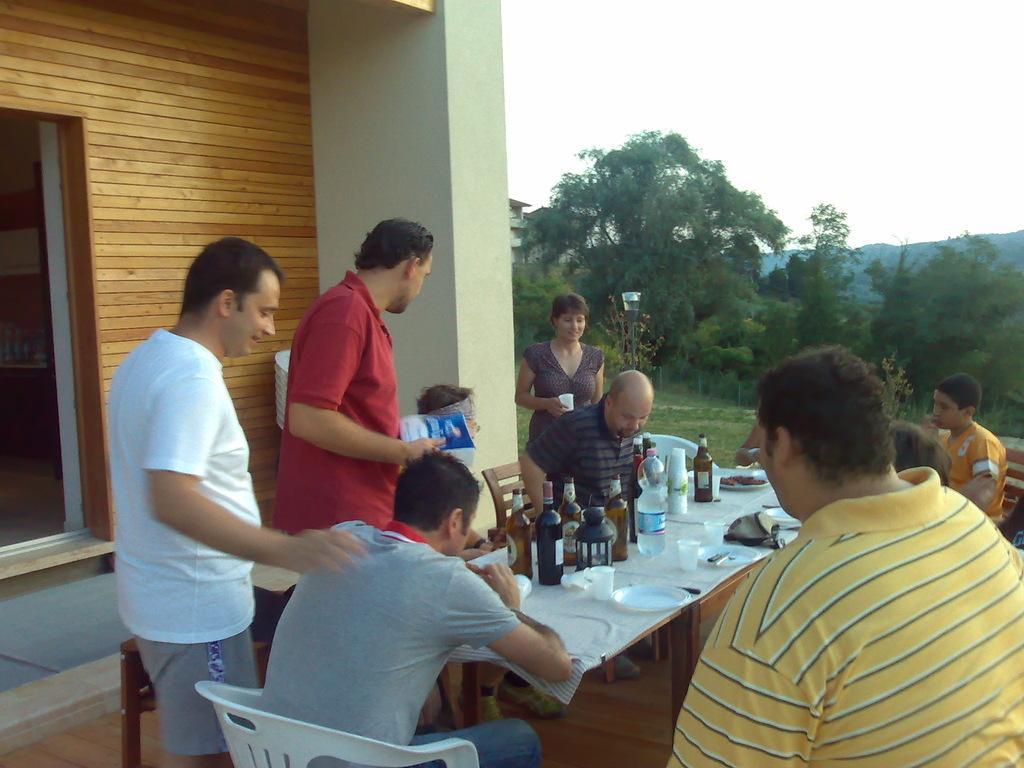How would you summarize this image in a sentence or two? In this image I can see number of people where few of them are standing and rest all are sitting. Here on this table I can see few bottles, plates and napkins. In the background I can see number of trees and building. 